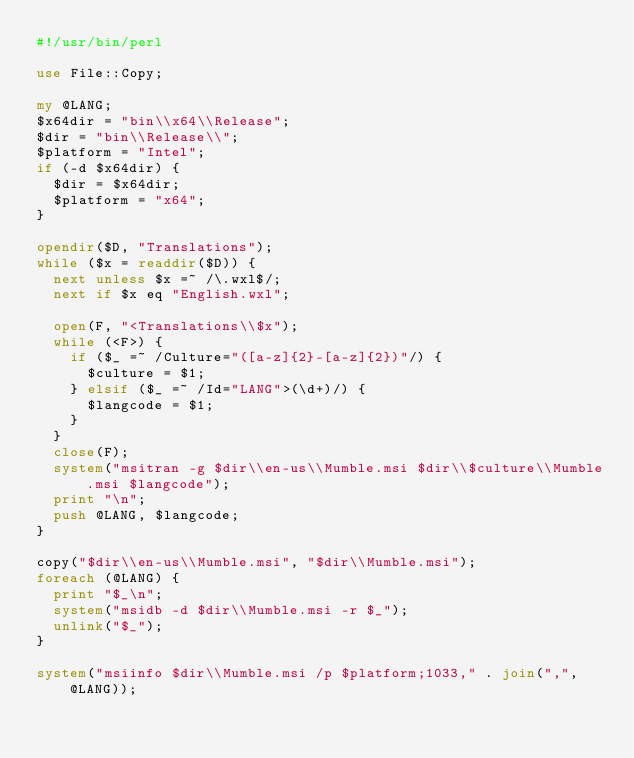Convert code to text. <code><loc_0><loc_0><loc_500><loc_500><_Perl_>#!/usr/bin/perl

use File::Copy;

my @LANG;
$x64dir = "bin\\x64\\Release";
$dir = "bin\\Release\\";
$platform = "Intel";
if (-d $x64dir) {
	$dir = $x64dir;
	$platform = "x64";
}

opendir($D, "Translations");
while ($x = readdir($D)) {
	next unless $x =~ /\.wxl$/;
	next if $x eq "English.wxl";

	open(F, "<Translations\\$x");
	while (<F>) {
		if ($_ =~ /Culture="([a-z]{2}-[a-z]{2})"/) {
			$culture = $1;
		} elsif ($_ =~ /Id="LANG">(\d+)/) {
			$langcode = $1;
		}
	}
	close(F);
	system("msitran -g $dir\\en-us\\Mumble.msi $dir\\$culture\\Mumble.msi $langcode");
	print "\n";
	push @LANG, $langcode;
}

copy("$dir\\en-us\\Mumble.msi", "$dir\\Mumble.msi");
foreach (@LANG) {
	print "$_\n";
	system("msidb -d $dir\\Mumble.msi -r $_");
	unlink("$_");
}

system("msiinfo $dir\\Mumble.msi /p $platform;1033," . join(",", @LANG));
</code> 